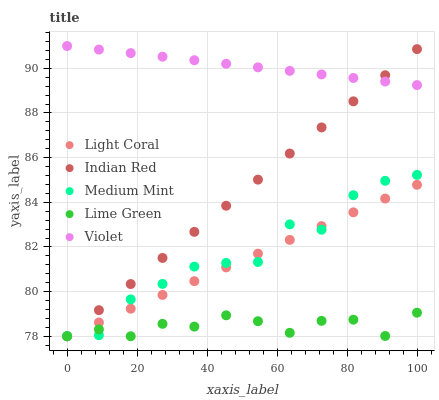Does Lime Green have the minimum area under the curve?
Answer yes or no. Yes. Does Violet have the maximum area under the curve?
Answer yes or no. Yes. Does Medium Mint have the minimum area under the curve?
Answer yes or no. No. Does Medium Mint have the maximum area under the curve?
Answer yes or no. No. Is Violet the smoothest?
Answer yes or no. Yes. Is Medium Mint the roughest?
Answer yes or no. Yes. Is Lime Green the smoothest?
Answer yes or no. No. Is Lime Green the roughest?
Answer yes or no. No. Does Light Coral have the lowest value?
Answer yes or no. Yes. Does Medium Mint have the lowest value?
Answer yes or no. No. Does Violet have the highest value?
Answer yes or no. Yes. Does Medium Mint have the highest value?
Answer yes or no. No. Is Medium Mint less than Violet?
Answer yes or no. Yes. Is Violet greater than Medium Mint?
Answer yes or no. Yes. Does Light Coral intersect Medium Mint?
Answer yes or no. Yes. Is Light Coral less than Medium Mint?
Answer yes or no. No. Is Light Coral greater than Medium Mint?
Answer yes or no. No. Does Medium Mint intersect Violet?
Answer yes or no. No. 